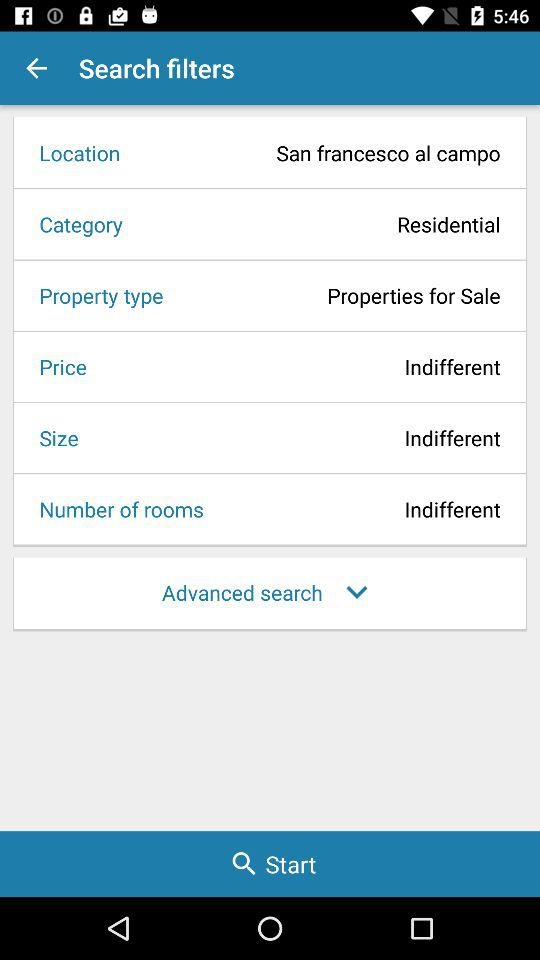How many search filters are there?
Answer the question using a single word or phrase. 6 